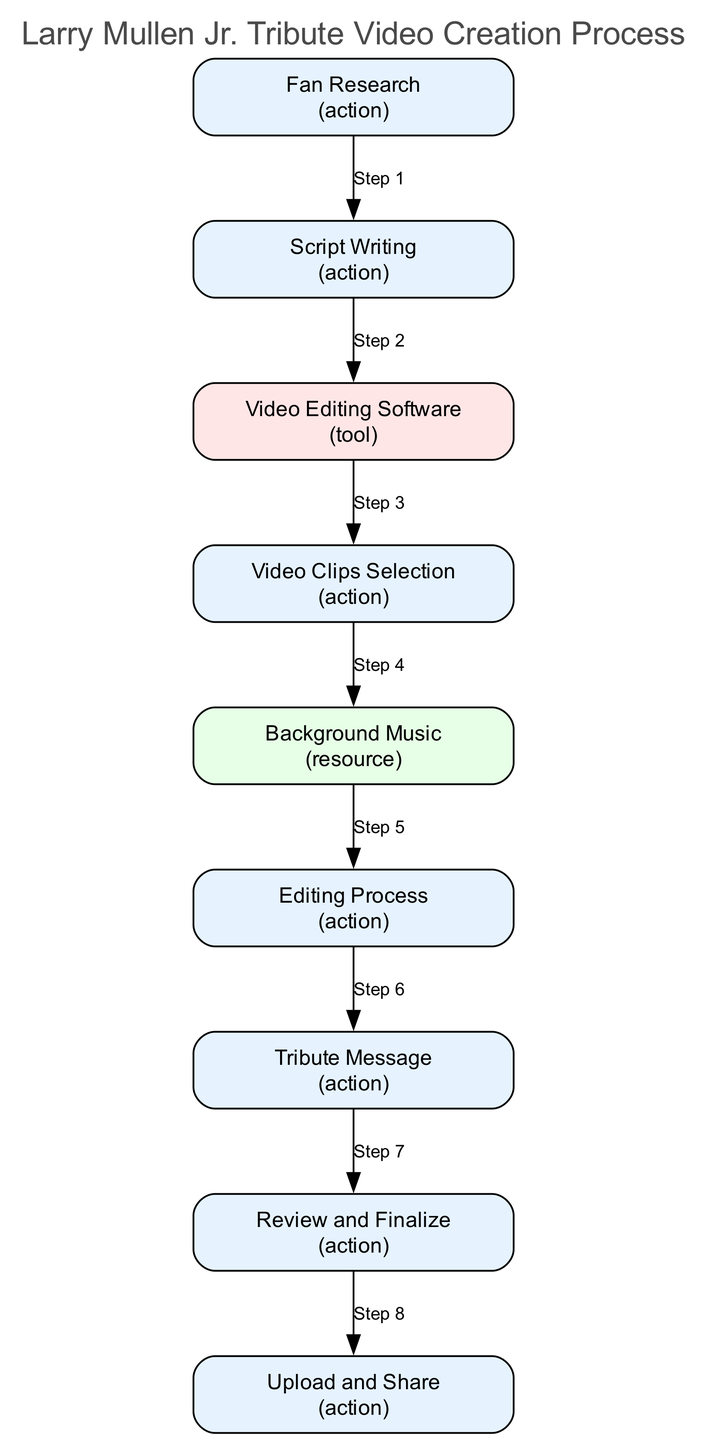What is the first action in the sequence? The first action in the sequence diagram is "Fan Research." This is the first node listed in the diagram's flow, indicating the initial step taken to create the tribute video.
Answer: Fan Research How many action nodes are there in total? There are seven action nodes in the diagram. These nodes are specifically for actions that need to be taken during the tribute video creation process.
Answer: 7 What is the last action before uploading the video? The last action before uploading the video is "Review and Finalize." This step ensures that everything is satisfactory before proceeding to share the finished product.
Answer: Review and Finalize Which node comes immediately after "Script Writing"? The node that comes immediately after "Script Writing" is "Video Clips Selection." This is the next step in the process after writing the script.
Answer: Video Clips Selection What type of element is "Video Editing Software"? "Video Editing Software" is a tool. In the diagram, this element category is distinguished by its description, indicating it’s necessary software for performing the editing tasks.
Answer: tool What two resources are selected before the Editing Process? Before the "Editing Process," "Video Clips Selection" and "Background Music" are the two resources selected. The selection of clips and music are integral to the editing phase.
Answer: Video Clips Selection and Background Music Which action directly precedes the "Upload and Share" step? The action that directly precedes the "Upload and Share" step is "Review and Finalize." This ensures everything is correct before sharing the tribute video with others.
Answer: Review and Finalize What is the purpose of the "Tribute Message"? The "Tribute Message" serves the purpose of expressing admiration for Larry Mullen, Jr. This heartfelt piece adds a personal touch to the video, enhancing its emotional impact.
Answer: expressing admiration After which action is music integrated into the video? Music is integrated into the video after the "Editing Process." This phase combines clips and music for synchronization, which occurs before finalizing the video.
Answer: Editing Process 